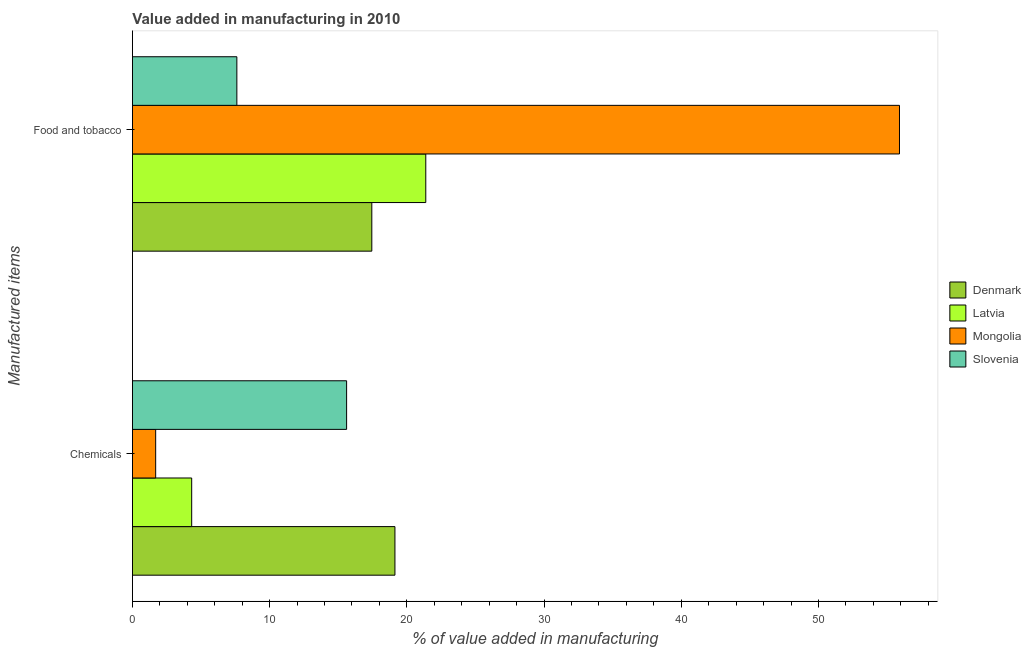How many groups of bars are there?
Make the answer very short. 2. Are the number of bars per tick equal to the number of legend labels?
Make the answer very short. Yes. How many bars are there on the 2nd tick from the top?
Ensure brevity in your answer.  4. How many bars are there on the 1st tick from the bottom?
Provide a succinct answer. 4. What is the label of the 1st group of bars from the top?
Offer a very short reply. Food and tobacco. What is the value added by manufacturing food and tobacco in Slovenia?
Offer a terse response. 7.61. Across all countries, what is the maximum value added by manufacturing food and tobacco?
Give a very brief answer. 55.9. Across all countries, what is the minimum value added by  manufacturing chemicals?
Provide a succinct answer. 1.69. In which country was the value added by manufacturing food and tobacco maximum?
Ensure brevity in your answer.  Mongolia. In which country was the value added by  manufacturing chemicals minimum?
Keep it short and to the point. Mongolia. What is the total value added by  manufacturing chemicals in the graph?
Ensure brevity in your answer.  40.75. What is the difference between the value added by manufacturing food and tobacco in Latvia and that in Denmark?
Keep it short and to the point. 3.93. What is the difference between the value added by  manufacturing chemicals in Mongolia and the value added by manufacturing food and tobacco in Denmark?
Ensure brevity in your answer.  -15.75. What is the average value added by  manufacturing chemicals per country?
Offer a very short reply. 10.19. What is the difference between the value added by  manufacturing chemicals and value added by manufacturing food and tobacco in Latvia?
Give a very brief answer. -17.06. In how many countries, is the value added by manufacturing food and tobacco greater than 28 %?
Offer a terse response. 1. What is the ratio of the value added by manufacturing food and tobacco in Latvia to that in Slovenia?
Your answer should be compact. 2.81. Is the value added by  manufacturing chemicals in Denmark less than that in Latvia?
Your response must be concise. No. In how many countries, is the value added by  manufacturing chemicals greater than the average value added by  manufacturing chemicals taken over all countries?
Your answer should be very brief. 2. What does the 3rd bar from the top in Chemicals represents?
Offer a terse response. Latvia. What does the 2nd bar from the bottom in Chemicals represents?
Your answer should be very brief. Latvia. Are all the bars in the graph horizontal?
Your answer should be compact. Yes. What is the difference between two consecutive major ticks on the X-axis?
Provide a succinct answer. 10. How are the legend labels stacked?
Your answer should be compact. Vertical. What is the title of the graph?
Your answer should be compact. Value added in manufacturing in 2010. Does "Guyana" appear as one of the legend labels in the graph?
Provide a short and direct response. No. What is the label or title of the X-axis?
Provide a succinct answer. % of value added in manufacturing. What is the label or title of the Y-axis?
Provide a short and direct response. Manufactured items. What is the % of value added in manufacturing of Denmark in Chemicals?
Give a very brief answer. 19.13. What is the % of value added in manufacturing of Latvia in Chemicals?
Provide a short and direct response. 4.32. What is the % of value added in manufacturing in Mongolia in Chemicals?
Your answer should be compact. 1.69. What is the % of value added in manufacturing of Slovenia in Chemicals?
Provide a short and direct response. 15.61. What is the % of value added in manufacturing of Denmark in Food and tobacco?
Your response must be concise. 17.45. What is the % of value added in manufacturing of Latvia in Food and tobacco?
Provide a succinct answer. 21.38. What is the % of value added in manufacturing in Mongolia in Food and tobacco?
Ensure brevity in your answer.  55.9. What is the % of value added in manufacturing in Slovenia in Food and tobacco?
Provide a succinct answer. 7.61. Across all Manufactured items, what is the maximum % of value added in manufacturing in Denmark?
Ensure brevity in your answer.  19.13. Across all Manufactured items, what is the maximum % of value added in manufacturing of Latvia?
Your response must be concise. 21.38. Across all Manufactured items, what is the maximum % of value added in manufacturing in Mongolia?
Provide a short and direct response. 55.9. Across all Manufactured items, what is the maximum % of value added in manufacturing of Slovenia?
Ensure brevity in your answer.  15.61. Across all Manufactured items, what is the minimum % of value added in manufacturing of Denmark?
Offer a very short reply. 17.45. Across all Manufactured items, what is the minimum % of value added in manufacturing of Latvia?
Give a very brief answer. 4.32. Across all Manufactured items, what is the minimum % of value added in manufacturing in Mongolia?
Your answer should be compact. 1.69. Across all Manufactured items, what is the minimum % of value added in manufacturing in Slovenia?
Give a very brief answer. 7.61. What is the total % of value added in manufacturing in Denmark in the graph?
Make the answer very short. 36.58. What is the total % of value added in manufacturing of Latvia in the graph?
Offer a very short reply. 25.7. What is the total % of value added in manufacturing of Mongolia in the graph?
Make the answer very short. 57.59. What is the total % of value added in manufacturing in Slovenia in the graph?
Offer a terse response. 23.22. What is the difference between the % of value added in manufacturing of Denmark in Chemicals and that in Food and tobacco?
Provide a short and direct response. 1.69. What is the difference between the % of value added in manufacturing in Latvia in Chemicals and that in Food and tobacco?
Provide a short and direct response. -17.06. What is the difference between the % of value added in manufacturing of Mongolia in Chemicals and that in Food and tobacco?
Ensure brevity in your answer.  -54.21. What is the difference between the % of value added in manufacturing of Slovenia in Chemicals and that in Food and tobacco?
Your answer should be very brief. 8. What is the difference between the % of value added in manufacturing in Denmark in Chemicals and the % of value added in manufacturing in Latvia in Food and tobacco?
Provide a short and direct response. -2.25. What is the difference between the % of value added in manufacturing in Denmark in Chemicals and the % of value added in manufacturing in Mongolia in Food and tobacco?
Provide a short and direct response. -36.77. What is the difference between the % of value added in manufacturing of Denmark in Chemicals and the % of value added in manufacturing of Slovenia in Food and tobacco?
Offer a very short reply. 11.52. What is the difference between the % of value added in manufacturing in Latvia in Chemicals and the % of value added in manufacturing in Mongolia in Food and tobacco?
Your answer should be compact. -51.58. What is the difference between the % of value added in manufacturing of Latvia in Chemicals and the % of value added in manufacturing of Slovenia in Food and tobacco?
Give a very brief answer. -3.29. What is the difference between the % of value added in manufacturing in Mongolia in Chemicals and the % of value added in manufacturing in Slovenia in Food and tobacco?
Your answer should be very brief. -5.92. What is the average % of value added in manufacturing in Denmark per Manufactured items?
Keep it short and to the point. 18.29. What is the average % of value added in manufacturing in Latvia per Manufactured items?
Make the answer very short. 12.85. What is the average % of value added in manufacturing of Mongolia per Manufactured items?
Offer a very short reply. 28.8. What is the average % of value added in manufacturing of Slovenia per Manufactured items?
Your answer should be compact. 11.61. What is the difference between the % of value added in manufacturing of Denmark and % of value added in manufacturing of Latvia in Chemicals?
Provide a succinct answer. 14.81. What is the difference between the % of value added in manufacturing in Denmark and % of value added in manufacturing in Mongolia in Chemicals?
Ensure brevity in your answer.  17.44. What is the difference between the % of value added in manufacturing in Denmark and % of value added in manufacturing in Slovenia in Chemicals?
Keep it short and to the point. 3.52. What is the difference between the % of value added in manufacturing of Latvia and % of value added in manufacturing of Mongolia in Chemicals?
Make the answer very short. 2.62. What is the difference between the % of value added in manufacturing in Latvia and % of value added in manufacturing in Slovenia in Chemicals?
Make the answer very short. -11.29. What is the difference between the % of value added in manufacturing of Mongolia and % of value added in manufacturing of Slovenia in Chemicals?
Offer a terse response. -13.91. What is the difference between the % of value added in manufacturing of Denmark and % of value added in manufacturing of Latvia in Food and tobacco?
Ensure brevity in your answer.  -3.93. What is the difference between the % of value added in manufacturing of Denmark and % of value added in manufacturing of Mongolia in Food and tobacco?
Your response must be concise. -38.45. What is the difference between the % of value added in manufacturing in Denmark and % of value added in manufacturing in Slovenia in Food and tobacco?
Provide a succinct answer. 9.84. What is the difference between the % of value added in manufacturing in Latvia and % of value added in manufacturing in Mongolia in Food and tobacco?
Offer a very short reply. -34.52. What is the difference between the % of value added in manufacturing in Latvia and % of value added in manufacturing in Slovenia in Food and tobacco?
Your response must be concise. 13.77. What is the difference between the % of value added in manufacturing in Mongolia and % of value added in manufacturing in Slovenia in Food and tobacco?
Your response must be concise. 48.29. What is the ratio of the % of value added in manufacturing in Denmark in Chemicals to that in Food and tobacco?
Your response must be concise. 1.1. What is the ratio of the % of value added in manufacturing of Latvia in Chemicals to that in Food and tobacco?
Your answer should be compact. 0.2. What is the ratio of the % of value added in manufacturing of Mongolia in Chemicals to that in Food and tobacco?
Make the answer very short. 0.03. What is the ratio of the % of value added in manufacturing in Slovenia in Chemicals to that in Food and tobacco?
Offer a terse response. 2.05. What is the difference between the highest and the second highest % of value added in manufacturing in Denmark?
Your answer should be compact. 1.69. What is the difference between the highest and the second highest % of value added in manufacturing in Latvia?
Offer a terse response. 17.06. What is the difference between the highest and the second highest % of value added in manufacturing of Mongolia?
Offer a very short reply. 54.21. What is the difference between the highest and the second highest % of value added in manufacturing of Slovenia?
Give a very brief answer. 8. What is the difference between the highest and the lowest % of value added in manufacturing of Denmark?
Make the answer very short. 1.69. What is the difference between the highest and the lowest % of value added in manufacturing of Latvia?
Keep it short and to the point. 17.06. What is the difference between the highest and the lowest % of value added in manufacturing of Mongolia?
Your answer should be very brief. 54.21. What is the difference between the highest and the lowest % of value added in manufacturing of Slovenia?
Your response must be concise. 8. 